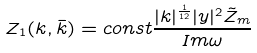<formula> <loc_0><loc_0><loc_500><loc_500>Z _ { 1 } ( k , \bar { k } ) = c o n s t \frac { | k | ^ { \frac { 1 } { 1 2 } } | y | ^ { 2 } \tilde { Z } _ { m } } { I m \omega }</formula> 